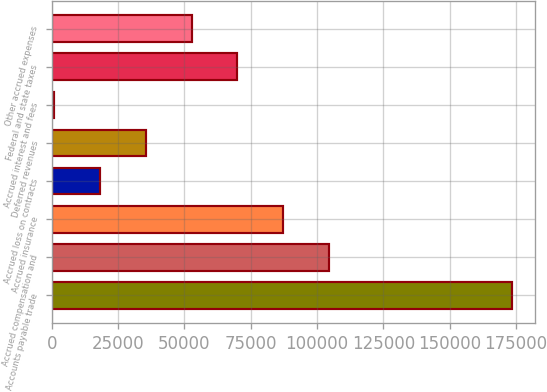Convert chart. <chart><loc_0><loc_0><loc_500><loc_500><bar_chart><fcel>Accounts payable trade<fcel>Accrued compensation and<fcel>Accrued insurance<fcel>Accrued loss on contracts<fcel>Deferred revenues<fcel>Accrued interest and fees<fcel>Federal and state taxes<fcel>Other accrued expenses<nl><fcel>173301<fcel>104391<fcel>87163.5<fcel>18253.5<fcel>35481<fcel>1026<fcel>69936<fcel>52708.5<nl></chart> 